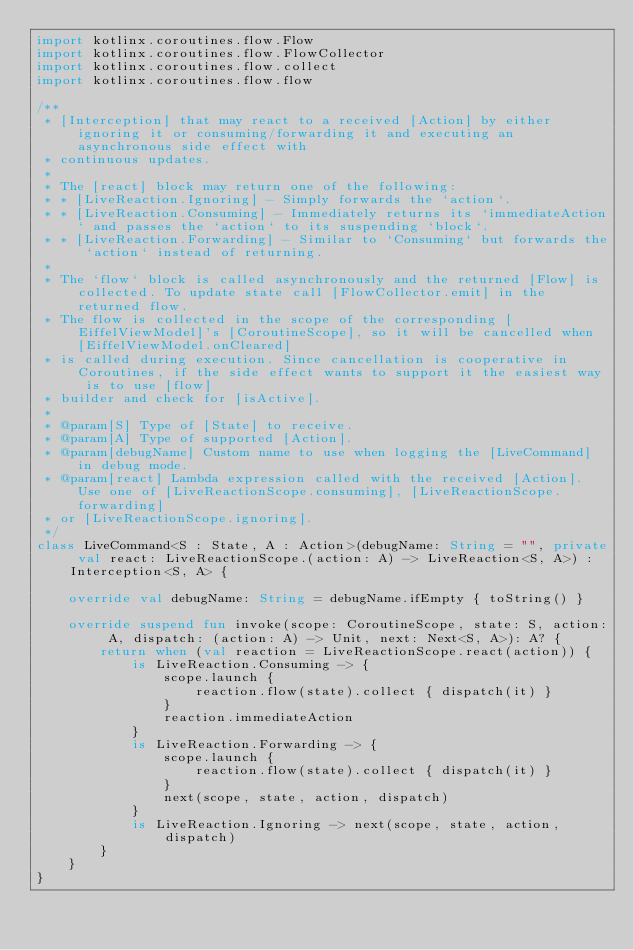Convert code to text. <code><loc_0><loc_0><loc_500><loc_500><_Kotlin_>import kotlinx.coroutines.flow.Flow
import kotlinx.coroutines.flow.FlowCollector
import kotlinx.coroutines.flow.collect
import kotlinx.coroutines.flow.flow

/**
 * [Interception] that may react to a received [Action] by either ignoring it or consuming/forwarding it and executing an asynchronous side effect with
 * continuous updates.
 *
 * The [react] block may return one of the following:
 * * [LiveReaction.Ignoring] - Simply forwards the `action`.
 * * [LiveReaction.Consuming] - Immediately returns its `immediateAction` and passes the `action` to its suspending `block`.
 * * [LiveReaction.Forwarding] - Similar to `Consuming` but forwards the `action` instead of returning.
 *
 * The `flow` block is called asynchronously and the returned [Flow] is collected. To update state call [FlowCollector.emit] in the returned flow.
 * The flow is collected in the scope of the corresponding [EiffelViewModel]'s [CoroutineScope], so it will be cancelled when [EiffelViewModel.onCleared]
 * is called during execution. Since cancellation is cooperative in Coroutines, if the side effect wants to support it the easiest way is to use [flow]
 * builder and check for [isActive].
 *
 * @param[S] Type of [State] to receive.
 * @param[A] Type of supported [Action].
 * @param[debugName] Custom name to use when logging the [LiveCommand] in debug mode.
 * @param[react] Lambda expression called with the received [Action]. Use one of [LiveReactionScope.consuming], [LiveReactionScope.forwarding]
 * or [LiveReactionScope.ignoring].
 */
class LiveCommand<S : State, A : Action>(debugName: String = "", private val react: LiveReactionScope.(action: A) -> LiveReaction<S, A>) : Interception<S, A> {

    override val debugName: String = debugName.ifEmpty { toString() }

    override suspend fun invoke(scope: CoroutineScope, state: S, action: A, dispatch: (action: A) -> Unit, next: Next<S, A>): A? {
        return when (val reaction = LiveReactionScope.react(action)) {
            is LiveReaction.Consuming -> {
                scope.launch {
                    reaction.flow(state).collect { dispatch(it) }
                }
                reaction.immediateAction
            }
            is LiveReaction.Forwarding -> {
                scope.launch {
                    reaction.flow(state).collect { dispatch(it) }
                }
                next(scope, state, action, dispatch)
            }
            is LiveReaction.Ignoring -> next(scope, state, action, dispatch)
        }
    }
}
</code> 